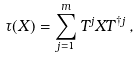<formula> <loc_0><loc_0><loc_500><loc_500>\tau ( X ) = \sum _ { j = 1 } ^ { m } T ^ { j } X T ^ { \dagger j } \, ,</formula> 